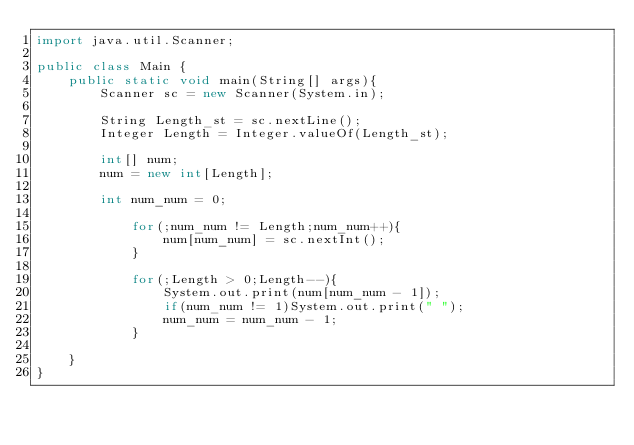Convert code to text. <code><loc_0><loc_0><loc_500><loc_500><_Java_>import java.util.Scanner;

public class Main {
	public static void main(String[] args){
		Scanner sc = new Scanner(System.in);

		String Length_st = sc.nextLine();
		Integer Length = Integer.valueOf(Length_st);

		int[] num;
		num = new int[Length];

		int num_num = 0;

			for(;num_num != Length;num_num++){
				num[num_num] = sc.nextInt();
			}
			
			for(;Length > 0;Length--){
				System.out.print(num[num_num - 1]);
				if(num_num != 1)System.out.print(" ");
				num_num = num_num - 1;
			}

	}
}</code> 